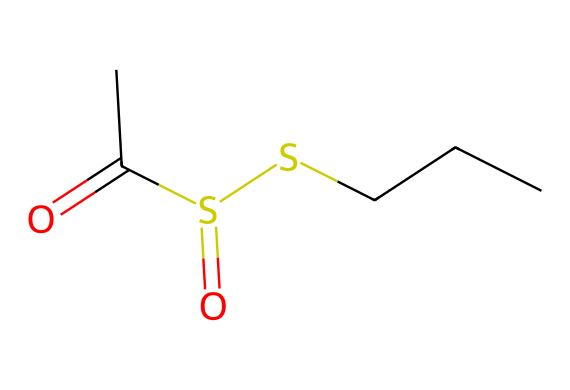What is the main functional group present in this molecule? The molecule contains a sulfonyl (S=O) functional group indicated by the sulfur atom bonded to two oxygen atoms with double bonds.
Answer: sulfonyl How many carbon atoms are in the structure of allicin? By analyzing the SMILES representation, we can count that there are three carbon atoms in the chain and one in the carbonyl (C=O), totaling four.
Answer: four What is the oxidation state of sulfur in this compound? In allicin, sulfur (S) is bonded to a carbon chain and has double bonds with oxygen. This indicates that the oxidation state of sulfur is +6 due to the increased number of bonds to oxygen compared to carbon.
Answer: +6 How many sulfur atoms are present in this compound? By examining the SMILES representation, we can identify that there are two sulfur atoms in the molecule.
Answer: two What type of compound is allicin classified as? Allicin is classified as a thiosulfinate, which is a sulfur compound characterized by having sulfur atoms with an oxidation state less than that of the sulfonyl group.
Answer: thiosulfinate Which part of the molecule is responsible for its pungent smell? The presence of the sulfur atoms and the specific arrangement within the molecule, including the thiosulfinate functional group, is responsible for allicin's characteristic pungent smell.
Answer: thiosulfinate 